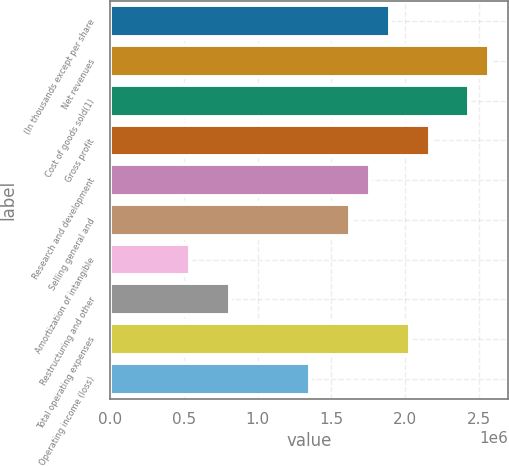<chart> <loc_0><loc_0><loc_500><loc_500><bar_chart><fcel>(In thousands except per share<fcel>Net revenues<fcel>Cost of goods sold(1)<fcel>Gross profit<fcel>Research and development<fcel>Selling general and<fcel>Amortization of intangible<fcel>Restructuring and other<fcel>Total operating expenses<fcel>Operating income (loss)<nl><fcel>1.89363e+06<fcel>2.56992e+06<fcel>2.43466e+06<fcel>2.16415e+06<fcel>1.75837e+06<fcel>1.62311e+06<fcel>541037<fcel>811555<fcel>2.02889e+06<fcel>1.35259e+06<nl></chart> 